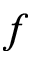<formula> <loc_0><loc_0><loc_500><loc_500>f</formula> 